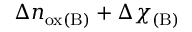Convert formula to latex. <formula><loc_0><loc_0><loc_500><loc_500>\Delta n _ { o x ( B ) } + \Delta \chi _ { ( B ) }</formula> 